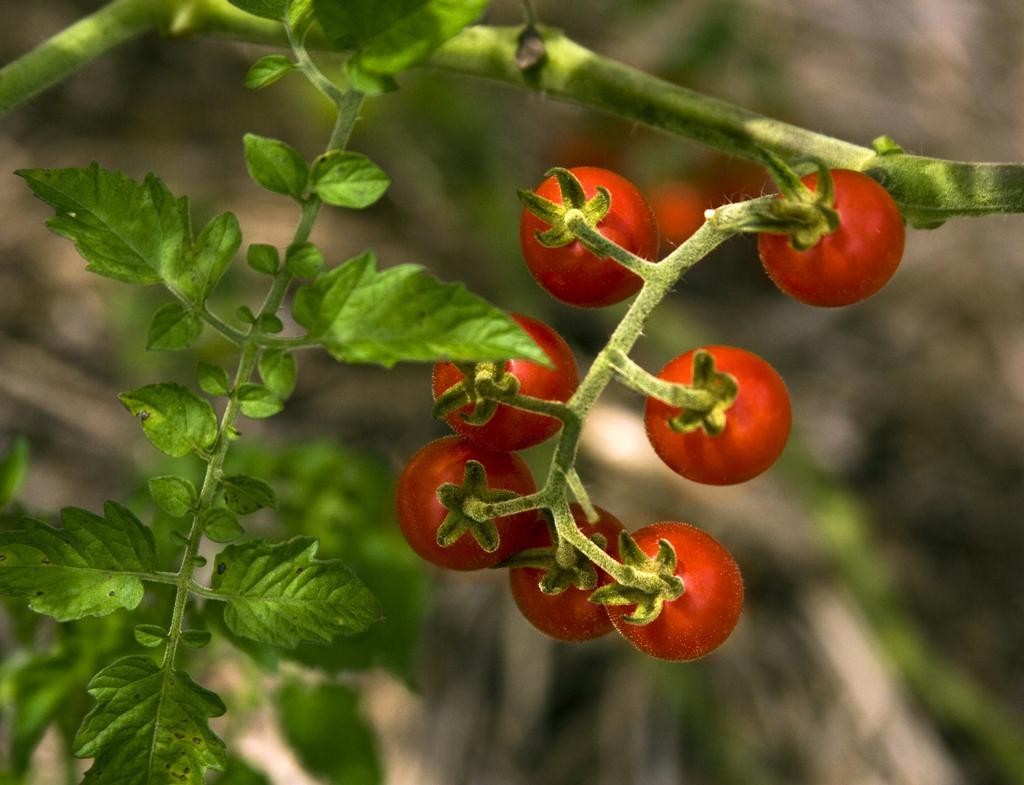Describe this image in one or two sentences. In this picture we can see tomatoes, leaves and blurry background. 